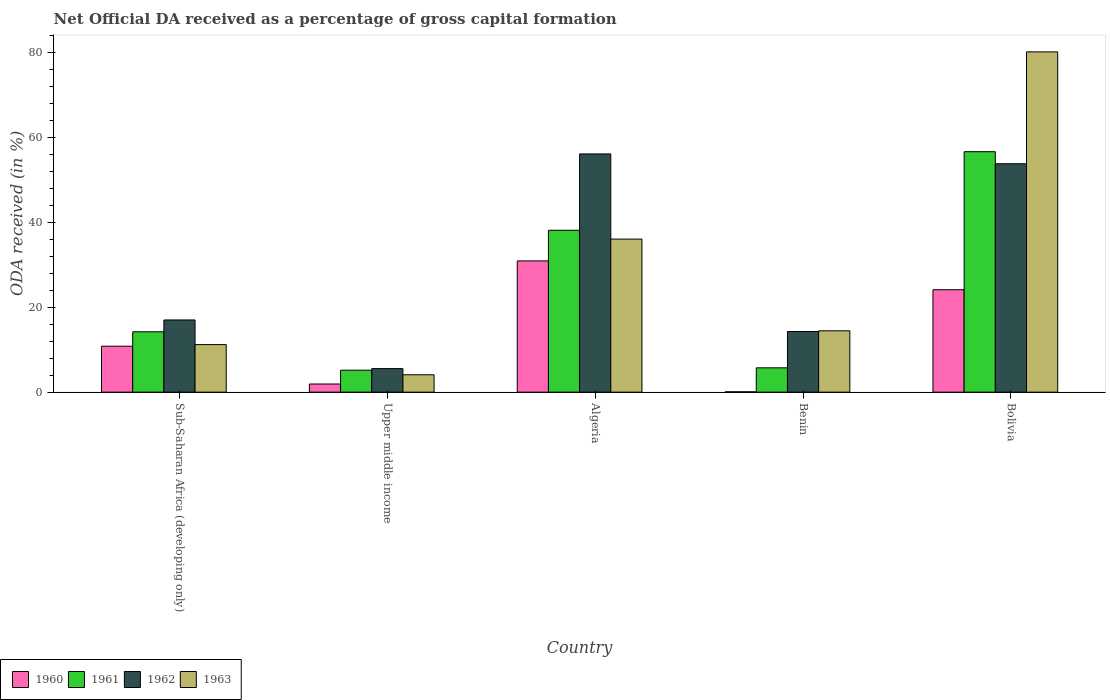How many groups of bars are there?
Offer a terse response. 5. Are the number of bars per tick equal to the number of legend labels?
Your answer should be compact. Yes. How many bars are there on the 5th tick from the left?
Keep it short and to the point. 4. What is the label of the 1st group of bars from the left?
Your response must be concise. Sub-Saharan Africa (developing only). In how many cases, is the number of bars for a given country not equal to the number of legend labels?
Provide a succinct answer. 0. What is the net ODA received in 1961 in Sub-Saharan Africa (developing only)?
Keep it short and to the point. 14.21. Across all countries, what is the maximum net ODA received in 1960?
Provide a short and direct response. 30.9. Across all countries, what is the minimum net ODA received in 1963?
Provide a short and direct response. 4.09. In which country was the net ODA received in 1960 maximum?
Your answer should be very brief. Algeria. In which country was the net ODA received in 1962 minimum?
Keep it short and to the point. Upper middle income. What is the total net ODA received in 1963 in the graph?
Give a very brief answer. 145.88. What is the difference between the net ODA received in 1960 in Benin and that in Sub-Saharan Africa (developing only)?
Keep it short and to the point. -10.74. What is the difference between the net ODA received in 1962 in Benin and the net ODA received in 1961 in Algeria?
Make the answer very short. -23.84. What is the average net ODA received in 1962 per country?
Ensure brevity in your answer.  29.34. What is the difference between the net ODA received of/in 1963 and net ODA received of/in 1961 in Algeria?
Make the answer very short. -2.08. What is the ratio of the net ODA received in 1961 in Algeria to that in Bolivia?
Offer a very short reply. 0.67. What is the difference between the highest and the second highest net ODA received in 1963?
Offer a terse response. 44.08. What is the difference between the highest and the lowest net ODA received in 1962?
Offer a terse response. 50.54. In how many countries, is the net ODA received in 1962 greater than the average net ODA received in 1962 taken over all countries?
Ensure brevity in your answer.  2. Is it the case that in every country, the sum of the net ODA received in 1960 and net ODA received in 1961 is greater than the sum of net ODA received in 1963 and net ODA received in 1962?
Keep it short and to the point. No. What does the 2nd bar from the left in Benin represents?
Offer a very short reply. 1961. What does the 2nd bar from the right in Sub-Saharan Africa (developing only) represents?
Your answer should be compact. 1962. Is it the case that in every country, the sum of the net ODA received in 1962 and net ODA received in 1961 is greater than the net ODA received in 1963?
Keep it short and to the point. Yes. Are all the bars in the graph horizontal?
Your answer should be compact. No. How many countries are there in the graph?
Your answer should be compact. 5. Are the values on the major ticks of Y-axis written in scientific E-notation?
Your answer should be very brief. No. Where does the legend appear in the graph?
Your response must be concise. Bottom left. How many legend labels are there?
Your answer should be very brief. 4. What is the title of the graph?
Offer a terse response. Net Official DA received as a percentage of gross capital formation. What is the label or title of the Y-axis?
Provide a short and direct response. ODA received (in %). What is the ODA received (in %) in 1960 in Sub-Saharan Africa (developing only)?
Your answer should be very brief. 10.82. What is the ODA received (in %) in 1961 in Sub-Saharan Africa (developing only)?
Offer a very short reply. 14.21. What is the ODA received (in %) of 1962 in Sub-Saharan Africa (developing only)?
Your answer should be very brief. 17. What is the ODA received (in %) of 1963 in Sub-Saharan Africa (developing only)?
Provide a succinct answer. 11.2. What is the ODA received (in %) in 1960 in Upper middle income?
Make the answer very short. 1.92. What is the ODA received (in %) in 1961 in Upper middle income?
Your answer should be very brief. 5.17. What is the ODA received (in %) of 1962 in Upper middle income?
Give a very brief answer. 5.54. What is the ODA received (in %) in 1963 in Upper middle income?
Provide a short and direct response. 4.09. What is the ODA received (in %) in 1960 in Algeria?
Offer a terse response. 30.9. What is the ODA received (in %) of 1961 in Algeria?
Ensure brevity in your answer.  38.11. What is the ODA received (in %) in 1962 in Algeria?
Keep it short and to the point. 56.09. What is the ODA received (in %) in 1963 in Algeria?
Offer a terse response. 36.04. What is the ODA received (in %) of 1960 in Benin?
Your response must be concise. 0.08. What is the ODA received (in %) in 1961 in Benin?
Make the answer very short. 5.73. What is the ODA received (in %) in 1962 in Benin?
Keep it short and to the point. 14.28. What is the ODA received (in %) of 1963 in Benin?
Your response must be concise. 14.44. What is the ODA received (in %) of 1960 in Bolivia?
Provide a short and direct response. 24.12. What is the ODA received (in %) of 1961 in Bolivia?
Ensure brevity in your answer.  56.62. What is the ODA received (in %) of 1962 in Bolivia?
Provide a short and direct response. 53.77. What is the ODA received (in %) in 1963 in Bolivia?
Offer a terse response. 80.11. Across all countries, what is the maximum ODA received (in %) of 1960?
Offer a very short reply. 30.9. Across all countries, what is the maximum ODA received (in %) in 1961?
Your answer should be compact. 56.62. Across all countries, what is the maximum ODA received (in %) of 1962?
Keep it short and to the point. 56.09. Across all countries, what is the maximum ODA received (in %) in 1963?
Give a very brief answer. 80.11. Across all countries, what is the minimum ODA received (in %) of 1960?
Ensure brevity in your answer.  0.08. Across all countries, what is the minimum ODA received (in %) of 1961?
Provide a succinct answer. 5.17. Across all countries, what is the minimum ODA received (in %) of 1962?
Ensure brevity in your answer.  5.54. Across all countries, what is the minimum ODA received (in %) in 1963?
Give a very brief answer. 4.09. What is the total ODA received (in %) of 1960 in the graph?
Provide a short and direct response. 67.83. What is the total ODA received (in %) of 1961 in the graph?
Offer a terse response. 119.84. What is the total ODA received (in %) of 1962 in the graph?
Your answer should be compact. 146.68. What is the total ODA received (in %) in 1963 in the graph?
Provide a succinct answer. 145.88. What is the difference between the ODA received (in %) of 1960 in Sub-Saharan Africa (developing only) and that in Upper middle income?
Offer a terse response. 8.9. What is the difference between the ODA received (in %) in 1961 in Sub-Saharan Africa (developing only) and that in Upper middle income?
Make the answer very short. 9.04. What is the difference between the ODA received (in %) of 1962 in Sub-Saharan Africa (developing only) and that in Upper middle income?
Your answer should be compact. 11.45. What is the difference between the ODA received (in %) of 1963 in Sub-Saharan Africa (developing only) and that in Upper middle income?
Offer a terse response. 7.11. What is the difference between the ODA received (in %) in 1960 in Sub-Saharan Africa (developing only) and that in Algeria?
Keep it short and to the point. -20.09. What is the difference between the ODA received (in %) of 1961 in Sub-Saharan Africa (developing only) and that in Algeria?
Give a very brief answer. -23.9. What is the difference between the ODA received (in %) of 1962 in Sub-Saharan Africa (developing only) and that in Algeria?
Make the answer very short. -39.09. What is the difference between the ODA received (in %) of 1963 in Sub-Saharan Africa (developing only) and that in Algeria?
Ensure brevity in your answer.  -24.84. What is the difference between the ODA received (in %) of 1960 in Sub-Saharan Africa (developing only) and that in Benin?
Offer a very short reply. 10.74. What is the difference between the ODA received (in %) of 1961 in Sub-Saharan Africa (developing only) and that in Benin?
Provide a succinct answer. 8.48. What is the difference between the ODA received (in %) of 1962 in Sub-Saharan Africa (developing only) and that in Benin?
Provide a succinct answer. 2.72. What is the difference between the ODA received (in %) of 1963 in Sub-Saharan Africa (developing only) and that in Benin?
Give a very brief answer. -3.25. What is the difference between the ODA received (in %) of 1960 in Sub-Saharan Africa (developing only) and that in Bolivia?
Keep it short and to the point. -13.3. What is the difference between the ODA received (in %) of 1961 in Sub-Saharan Africa (developing only) and that in Bolivia?
Your answer should be very brief. -42.41. What is the difference between the ODA received (in %) in 1962 in Sub-Saharan Africa (developing only) and that in Bolivia?
Your answer should be compact. -36.78. What is the difference between the ODA received (in %) of 1963 in Sub-Saharan Africa (developing only) and that in Bolivia?
Your response must be concise. -68.92. What is the difference between the ODA received (in %) of 1960 in Upper middle income and that in Algeria?
Give a very brief answer. -28.99. What is the difference between the ODA received (in %) of 1961 in Upper middle income and that in Algeria?
Offer a very short reply. -32.94. What is the difference between the ODA received (in %) in 1962 in Upper middle income and that in Algeria?
Make the answer very short. -50.54. What is the difference between the ODA received (in %) in 1963 in Upper middle income and that in Algeria?
Keep it short and to the point. -31.95. What is the difference between the ODA received (in %) in 1960 in Upper middle income and that in Benin?
Your answer should be compact. 1.84. What is the difference between the ODA received (in %) in 1961 in Upper middle income and that in Benin?
Provide a short and direct response. -0.56. What is the difference between the ODA received (in %) in 1962 in Upper middle income and that in Benin?
Provide a succinct answer. -8.73. What is the difference between the ODA received (in %) in 1963 in Upper middle income and that in Benin?
Provide a short and direct response. -10.35. What is the difference between the ODA received (in %) in 1960 in Upper middle income and that in Bolivia?
Your answer should be compact. -22.2. What is the difference between the ODA received (in %) of 1961 in Upper middle income and that in Bolivia?
Provide a succinct answer. -51.45. What is the difference between the ODA received (in %) in 1962 in Upper middle income and that in Bolivia?
Your response must be concise. -48.23. What is the difference between the ODA received (in %) of 1963 in Upper middle income and that in Bolivia?
Provide a short and direct response. -76.03. What is the difference between the ODA received (in %) of 1960 in Algeria and that in Benin?
Provide a short and direct response. 30.82. What is the difference between the ODA received (in %) in 1961 in Algeria and that in Benin?
Keep it short and to the point. 32.39. What is the difference between the ODA received (in %) of 1962 in Algeria and that in Benin?
Offer a terse response. 41.81. What is the difference between the ODA received (in %) of 1963 in Algeria and that in Benin?
Your answer should be very brief. 21.6. What is the difference between the ODA received (in %) in 1960 in Algeria and that in Bolivia?
Keep it short and to the point. 6.78. What is the difference between the ODA received (in %) of 1961 in Algeria and that in Bolivia?
Ensure brevity in your answer.  -18.5. What is the difference between the ODA received (in %) in 1962 in Algeria and that in Bolivia?
Ensure brevity in your answer.  2.31. What is the difference between the ODA received (in %) in 1963 in Algeria and that in Bolivia?
Make the answer very short. -44.08. What is the difference between the ODA received (in %) of 1960 in Benin and that in Bolivia?
Ensure brevity in your answer.  -24.04. What is the difference between the ODA received (in %) of 1961 in Benin and that in Bolivia?
Your response must be concise. -50.89. What is the difference between the ODA received (in %) of 1962 in Benin and that in Bolivia?
Keep it short and to the point. -39.5. What is the difference between the ODA received (in %) in 1963 in Benin and that in Bolivia?
Your answer should be very brief. -65.67. What is the difference between the ODA received (in %) of 1960 in Sub-Saharan Africa (developing only) and the ODA received (in %) of 1961 in Upper middle income?
Your response must be concise. 5.65. What is the difference between the ODA received (in %) in 1960 in Sub-Saharan Africa (developing only) and the ODA received (in %) in 1962 in Upper middle income?
Your answer should be very brief. 5.27. What is the difference between the ODA received (in %) in 1960 in Sub-Saharan Africa (developing only) and the ODA received (in %) in 1963 in Upper middle income?
Your answer should be very brief. 6.73. What is the difference between the ODA received (in %) in 1961 in Sub-Saharan Africa (developing only) and the ODA received (in %) in 1962 in Upper middle income?
Give a very brief answer. 8.67. What is the difference between the ODA received (in %) of 1961 in Sub-Saharan Africa (developing only) and the ODA received (in %) of 1963 in Upper middle income?
Your answer should be very brief. 10.12. What is the difference between the ODA received (in %) in 1962 in Sub-Saharan Africa (developing only) and the ODA received (in %) in 1963 in Upper middle income?
Provide a succinct answer. 12.91. What is the difference between the ODA received (in %) of 1960 in Sub-Saharan Africa (developing only) and the ODA received (in %) of 1961 in Algeria?
Give a very brief answer. -27.3. What is the difference between the ODA received (in %) of 1960 in Sub-Saharan Africa (developing only) and the ODA received (in %) of 1962 in Algeria?
Make the answer very short. -45.27. What is the difference between the ODA received (in %) in 1960 in Sub-Saharan Africa (developing only) and the ODA received (in %) in 1963 in Algeria?
Ensure brevity in your answer.  -25.22. What is the difference between the ODA received (in %) of 1961 in Sub-Saharan Africa (developing only) and the ODA received (in %) of 1962 in Algeria?
Your answer should be very brief. -41.88. What is the difference between the ODA received (in %) of 1961 in Sub-Saharan Africa (developing only) and the ODA received (in %) of 1963 in Algeria?
Keep it short and to the point. -21.83. What is the difference between the ODA received (in %) of 1962 in Sub-Saharan Africa (developing only) and the ODA received (in %) of 1963 in Algeria?
Your answer should be compact. -19.04. What is the difference between the ODA received (in %) of 1960 in Sub-Saharan Africa (developing only) and the ODA received (in %) of 1961 in Benin?
Your answer should be compact. 5.09. What is the difference between the ODA received (in %) in 1960 in Sub-Saharan Africa (developing only) and the ODA received (in %) in 1962 in Benin?
Ensure brevity in your answer.  -3.46. What is the difference between the ODA received (in %) in 1960 in Sub-Saharan Africa (developing only) and the ODA received (in %) in 1963 in Benin?
Offer a terse response. -3.62. What is the difference between the ODA received (in %) in 1961 in Sub-Saharan Africa (developing only) and the ODA received (in %) in 1962 in Benin?
Provide a succinct answer. -0.07. What is the difference between the ODA received (in %) of 1961 in Sub-Saharan Africa (developing only) and the ODA received (in %) of 1963 in Benin?
Offer a very short reply. -0.23. What is the difference between the ODA received (in %) in 1962 in Sub-Saharan Africa (developing only) and the ODA received (in %) in 1963 in Benin?
Your answer should be compact. 2.56. What is the difference between the ODA received (in %) of 1960 in Sub-Saharan Africa (developing only) and the ODA received (in %) of 1961 in Bolivia?
Your answer should be compact. -45.8. What is the difference between the ODA received (in %) of 1960 in Sub-Saharan Africa (developing only) and the ODA received (in %) of 1962 in Bolivia?
Your answer should be compact. -42.96. What is the difference between the ODA received (in %) of 1960 in Sub-Saharan Africa (developing only) and the ODA received (in %) of 1963 in Bolivia?
Your answer should be very brief. -69.3. What is the difference between the ODA received (in %) of 1961 in Sub-Saharan Africa (developing only) and the ODA received (in %) of 1962 in Bolivia?
Offer a very short reply. -39.56. What is the difference between the ODA received (in %) of 1961 in Sub-Saharan Africa (developing only) and the ODA received (in %) of 1963 in Bolivia?
Keep it short and to the point. -65.91. What is the difference between the ODA received (in %) in 1962 in Sub-Saharan Africa (developing only) and the ODA received (in %) in 1963 in Bolivia?
Provide a succinct answer. -63.12. What is the difference between the ODA received (in %) in 1960 in Upper middle income and the ODA received (in %) in 1961 in Algeria?
Your answer should be very brief. -36.2. What is the difference between the ODA received (in %) in 1960 in Upper middle income and the ODA received (in %) in 1962 in Algeria?
Ensure brevity in your answer.  -54.17. What is the difference between the ODA received (in %) of 1960 in Upper middle income and the ODA received (in %) of 1963 in Algeria?
Provide a succinct answer. -34.12. What is the difference between the ODA received (in %) in 1961 in Upper middle income and the ODA received (in %) in 1962 in Algeria?
Ensure brevity in your answer.  -50.92. What is the difference between the ODA received (in %) of 1961 in Upper middle income and the ODA received (in %) of 1963 in Algeria?
Offer a very short reply. -30.87. What is the difference between the ODA received (in %) of 1962 in Upper middle income and the ODA received (in %) of 1963 in Algeria?
Provide a succinct answer. -30.49. What is the difference between the ODA received (in %) of 1960 in Upper middle income and the ODA received (in %) of 1961 in Benin?
Give a very brief answer. -3.81. What is the difference between the ODA received (in %) in 1960 in Upper middle income and the ODA received (in %) in 1962 in Benin?
Make the answer very short. -12.36. What is the difference between the ODA received (in %) in 1960 in Upper middle income and the ODA received (in %) in 1963 in Benin?
Your response must be concise. -12.53. What is the difference between the ODA received (in %) in 1961 in Upper middle income and the ODA received (in %) in 1962 in Benin?
Your response must be concise. -9.11. What is the difference between the ODA received (in %) of 1961 in Upper middle income and the ODA received (in %) of 1963 in Benin?
Provide a short and direct response. -9.27. What is the difference between the ODA received (in %) in 1962 in Upper middle income and the ODA received (in %) in 1963 in Benin?
Provide a succinct answer. -8.9. What is the difference between the ODA received (in %) in 1960 in Upper middle income and the ODA received (in %) in 1961 in Bolivia?
Offer a terse response. -54.7. What is the difference between the ODA received (in %) in 1960 in Upper middle income and the ODA received (in %) in 1962 in Bolivia?
Offer a terse response. -51.86. What is the difference between the ODA received (in %) of 1960 in Upper middle income and the ODA received (in %) of 1963 in Bolivia?
Offer a very short reply. -78.2. What is the difference between the ODA received (in %) in 1961 in Upper middle income and the ODA received (in %) in 1962 in Bolivia?
Keep it short and to the point. -48.6. What is the difference between the ODA received (in %) of 1961 in Upper middle income and the ODA received (in %) of 1963 in Bolivia?
Give a very brief answer. -74.94. What is the difference between the ODA received (in %) of 1962 in Upper middle income and the ODA received (in %) of 1963 in Bolivia?
Provide a short and direct response. -74.57. What is the difference between the ODA received (in %) of 1960 in Algeria and the ODA received (in %) of 1961 in Benin?
Provide a succinct answer. 25.17. What is the difference between the ODA received (in %) of 1960 in Algeria and the ODA received (in %) of 1962 in Benin?
Your answer should be very brief. 16.62. What is the difference between the ODA received (in %) of 1960 in Algeria and the ODA received (in %) of 1963 in Benin?
Make the answer very short. 16.46. What is the difference between the ODA received (in %) of 1961 in Algeria and the ODA received (in %) of 1962 in Benin?
Keep it short and to the point. 23.84. What is the difference between the ODA received (in %) in 1961 in Algeria and the ODA received (in %) in 1963 in Benin?
Ensure brevity in your answer.  23.67. What is the difference between the ODA received (in %) of 1962 in Algeria and the ODA received (in %) of 1963 in Benin?
Give a very brief answer. 41.65. What is the difference between the ODA received (in %) of 1960 in Algeria and the ODA received (in %) of 1961 in Bolivia?
Your response must be concise. -25.71. What is the difference between the ODA received (in %) of 1960 in Algeria and the ODA received (in %) of 1962 in Bolivia?
Your answer should be compact. -22.87. What is the difference between the ODA received (in %) in 1960 in Algeria and the ODA received (in %) in 1963 in Bolivia?
Make the answer very short. -49.21. What is the difference between the ODA received (in %) in 1961 in Algeria and the ODA received (in %) in 1962 in Bolivia?
Give a very brief answer. -15.66. What is the difference between the ODA received (in %) in 1961 in Algeria and the ODA received (in %) in 1963 in Bolivia?
Ensure brevity in your answer.  -42. What is the difference between the ODA received (in %) of 1962 in Algeria and the ODA received (in %) of 1963 in Bolivia?
Ensure brevity in your answer.  -24.03. What is the difference between the ODA received (in %) of 1960 in Benin and the ODA received (in %) of 1961 in Bolivia?
Provide a short and direct response. -56.54. What is the difference between the ODA received (in %) of 1960 in Benin and the ODA received (in %) of 1962 in Bolivia?
Offer a terse response. -53.7. What is the difference between the ODA received (in %) of 1960 in Benin and the ODA received (in %) of 1963 in Bolivia?
Give a very brief answer. -80.04. What is the difference between the ODA received (in %) in 1961 in Benin and the ODA received (in %) in 1962 in Bolivia?
Provide a succinct answer. -48.05. What is the difference between the ODA received (in %) of 1961 in Benin and the ODA received (in %) of 1963 in Bolivia?
Provide a short and direct response. -74.39. What is the difference between the ODA received (in %) of 1962 in Benin and the ODA received (in %) of 1963 in Bolivia?
Your answer should be compact. -65.84. What is the average ODA received (in %) in 1960 per country?
Your answer should be compact. 13.57. What is the average ODA received (in %) of 1961 per country?
Offer a very short reply. 23.97. What is the average ODA received (in %) of 1962 per country?
Offer a terse response. 29.34. What is the average ODA received (in %) of 1963 per country?
Keep it short and to the point. 29.18. What is the difference between the ODA received (in %) of 1960 and ODA received (in %) of 1961 in Sub-Saharan Africa (developing only)?
Keep it short and to the point. -3.39. What is the difference between the ODA received (in %) in 1960 and ODA received (in %) in 1962 in Sub-Saharan Africa (developing only)?
Your answer should be compact. -6.18. What is the difference between the ODA received (in %) of 1960 and ODA received (in %) of 1963 in Sub-Saharan Africa (developing only)?
Provide a succinct answer. -0.38. What is the difference between the ODA received (in %) in 1961 and ODA received (in %) in 1962 in Sub-Saharan Africa (developing only)?
Keep it short and to the point. -2.79. What is the difference between the ODA received (in %) of 1961 and ODA received (in %) of 1963 in Sub-Saharan Africa (developing only)?
Make the answer very short. 3.01. What is the difference between the ODA received (in %) in 1962 and ODA received (in %) in 1963 in Sub-Saharan Africa (developing only)?
Offer a very short reply. 5.8. What is the difference between the ODA received (in %) of 1960 and ODA received (in %) of 1961 in Upper middle income?
Your answer should be very brief. -3.25. What is the difference between the ODA received (in %) in 1960 and ODA received (in %) in 1962 in Upper middle income?
Offer a terse response. -3.63. What is the difference between the ODA received (in %) in 1960 and ODA received (in %) in 1963 in Upper middle income?
Provide a succinct answer. -2.17. What is the difference between the ODA received (in %) of 1961 and ODA received (in %) of 1962 in Upper middle income?
Provide a succinct answer. -0.37. What is the difference between the ODA received (in %) in 1961 and ODA received (in %) in 1963 in Upper middle income?
Provide a succinct answer. 1.08. What is the difference between the ODA received (in %) of 1962 and ODA received (in %) of 1963 in Upper middle income?
Keep it short and to the point. 1.46. What is the difference between the ODA received (in %) in 1960 and ODA received (in %) in 1961 in Algeria?
Offer a very short reply. -7.21. What is the difference between the ODA received (in %) in 1960 and ODA received (in %) in 1962 in Algeria?
Your answer should be compact. -25.19. What is the difference between the ODA received (in %) in 1960 and ODA received (in %) in 1963 in Algeria?
Provide a succinct answer. -5.14. What is the difference between the ODA received (in %) in 1961 and ODA received (in %) in 1962 in Algeria?
Keep it short and to the point. -17.98. What is the difference between the ODA received (in %) of 1961 and ODA received (in %) of 1963 in Algeria?
Ensure brevity in your answer.  2.08. What is the difference between the ODA received (in %) in 1962 and ODA received (in %) in 1963 in Algeria?
Offer a terse response. 20.05. What is the difference between the ODA received (in %) in 1960 and ODA received (in %) in 1961 in Benin?
Keep it short and to the point. -5.65. What is the difference between the ODA received (in %) of 1960 and ODA received (in %) of 1962 in Benin?
Your answer should be compact. -14.2. What is the difference between the ODA received (in %) in 1960 and ODA received (in %) in 1963 in Benin?
Provide a short and direct response. -14.36. What is the difference between the ODA received (in %) in 1961 and ODA received (in %) in 1962 in Benin?
Provide a short and direct response. -8.55. What is the difference between the ODA received (in %) in 1961 and ODA received (in %) in 1963 in Benin?
Your answer should be very brief. -8.71. What is the difference between the ODA received (in %) in 1962 and ODA received (in %) in 1963 in Benin?
Your answer should be compact. -0.16. What is the difference between the ODA received (in %) in 1960 and ODA received (in %) in 1961 in Bolivia?
Keep it short and to the point. -32.5. What is the difference between the ODA received (in %) of 1960 and ODA received (in %) of 1962 in Bolivia?
Make the answer very short. -29.66. What is the difference between the ODA received (in %) in 1960 and ODA received (in %) in 1963 in Bolivia?
Give a very brief answer. -56. What is the difference between the ODA received (in %) in 1961 and ODA received (in %) in 1962 in Bolivia?
Your answer should be very brief. 2.84. What is the difference between the ODA received (in %) in 1961 and ODA received (in %) in 1963 in Bolivia?
Provide a short and direct response. -23.5. What is the difference between the ODA received (in %) of 1962 and ODA received (in %) of 1963 in Bolivia?
Make the answer very short. -26.34. What is the ratio of the ODA received (in %) in 1960 in Sub-Saharan Africa (developing only) to that in Upper middle income?
Give a very brief answer. 5.65. What is the ratio of the ODA received (in %) of 1961 in Sub-Saharan Africa (developing only) to that in Upper middle income?
Your response must be concise. 2.75. What is the ratio of the ODA received (in %) of 1962 in Sub-Saharan Africa (developing only) to that in Upper middle income?
Offer a very short reply. 3.07. What is the ratio of the ODA received (in %) of 1963 in Sub-Saharan Africa (developing only) to that in Upper middle income?
Give a very brief answer. 2.74. What is the ratio of the ODA received (in %) in 1961 in Sub-Saharan Africa (developing only) to that in Algeria?
Give a very brief answer. 0.37. What is the ratio of the ODA received (in %) of 1962 in Sub-Saharan Africa (developing only) to that in Algeria?
Offer a very short reply. 0.3. What is the ratio of the ODA received (in %) of 1963 in Sub-Saharan Africa (developing only) to that in Algeria?
Your answer should be compact. 0.31. What is the ratio of the ODA received (in %) of 1960 in Sub-Saharan Africa (developing only) to that in Benin?
Offer a very short reply. 139.77. What is the ratio of the ODA received (in %) of 1961 in Sub-Saharan Africa (developing only) to that in Benin?
Your answer should be compact. 2.48. What is the ratio of the ODA received (in %) of 1962 in Sub-Saharan Africa (developing only) to that in Benin?
Provide a short and direct response. 1.19. What is the ratio of the ODA received (in %) in 1963 in Sub-Saharan Africa (developing only) to that in Benin?
Give a very brief answer. 0.78. What is the ratio of the ODA received (in %) in 1960 in Sub-Saharan Africa (developing only) to that in Bolivia?
Keep it short and to the point. 0.45. What is the ratio of the ODA received (in %) in 1961 in Sub-Saharan Africa (developing only) to that in Bolivia?
Your answer should be compact. 0.25. What is the ratio of the ODA received (in %) of 1962 in Sub-Saharan Africa (developing only) to that in Bolivia?
Give a very brief answer. 0.32. What is the ratio of the ODA received (in %) in 1963 in Sub-Saharan Africa (developing only) to that in Bolivia?
Your answer should be compact. 0.14. What is the ratio of the ODA received (in %) of 1960 in Upper middle income to that in Algeria?
Give a very brief answer. 0.06. What is the ratio of the ODA received (in %) in 1961 in Upper middle income to that in Algeria?
Offer a terse response. 0.14. What is the ratio of the ODA received (in %) of 1962 in Upper middle income to that in Algeria?
Keep it short and to the point. 0.1. What is the ratio of the ODA received (in %) in 1963 in Upper middle income to that in Algeria?
Your answer should be very brief. 0.11. What is the ratio of the ODA received (in %) in 1960 in Upper middle income to that in Benin?
Ensure brevity in your answer.  24.75. What is the ratio of the ODA received (in %) of 1961 in Upper middle income to that in Benin?
Ensure brevity in your answer.  0.9. What is the ratio of the ODA received (in %) of 1962 in Upper middle income to that in Benin?
Offer a very short reply. 0.39. What is the ratio of the ODA received (in %) in 1963 in Upper middle income to that in Benin?
Offer a very short reply. 0.28. What is the ratio of the ODA received (in %) of 1960 in Upper middle income to that in Bolivia?
Offer a very short reply. 0.08. What is the ratio of the ODA received (in %) in 1961 in Upper middle income to that in Bolivia?
Give a very brief answer. 0.09. What is the ratio of the ODA received (in %) in 1962 in Upper middle income to that in Bolivia?
Offer a terse response. 0.1. What is the ratio of the ODA received (in %) in 1963 in Upper middle income to that in Bolivia?
Give a very brief answer. 0.05. What is the ratio of the ODA received (in %) of 1960 in Algeria to that in Benin?
Offer a terse response. 399.3. What is the ratio of the ODA received (in %) in 1961 in Algeria to that in Benin?
Offer a very short reply. 6.65. What is the ratio of the ODA received (in %) of 1962 in Algeria to that in Benin?
Your answer should be very brief. 3.93. What is the ratio of the ODA received (in %) of 1963 in Algeria to that in Benin?
Give a very brief answer. 2.5. What is the ratio of the ODA received (in %) in 1960 in Algeria to that in Bolivia?
Give a very brief answer. 1.28. What is the ratio of the ODA received (in %) of 1961 in Algeria to that in Bolivia?
Your response must be concise. 0.67. What is the ratio of the ODA received (in %) of 1962 in Algeria to that in Bolivia?
Your answer should be very brief. 1.04. What is the ratio of the ODA received (in %) of 1963 in Algeria to that in Bolivia?
Offer a terse response. 0.45. What is the ratio of the ODA received (in %) of 1960 in Benin to that in Bolivia?
Provide a short and direct response. 0. What is the ratio of the ODA received (in %) in 1961 in Benin to that in Bolivia?
Offer a terse response. 0.1. What is the ratio of the ODA received (in %) in 1962 in Benin to that in Bolivia?
Provide a succinct answer. 0.27. What is the ratio of the ODA received (in %) of 1963 in Benin to that in Bolivia?
Provide a short and direct response. 0.18. What is the difference between the highest and the second highest ODA received (in %) in 1960?
Your answer should be compact. 6.78. What is the difference between the highest and the second highest ODA received (in %) in 1961?
Provide a succinct answer. 18.5. What is the difference between the highest and the second highest ODA received (in %) in 1962?
Provide a short and direct response. 2.31. What is the difference between the highest and the second highest ODA received (in %) in 1963?
Ensure brevity in your answer.  44.08. What is the difference between the highest and the lowest ODA received (in %) in 1960?
Ensure brevity in your answer.  30.82. What is the difference between the highest and the lowest ODA received (in %) of 1961?
Your answer should be compact. 51.45. What is the difference between the highest and the lowest ODA received (in %) in 1962?
Your response must be concise. 50.54. What is the difference between the highest and the lowest ODA received (in %) in 1963?
Provide a succinct answer. 76.03. 